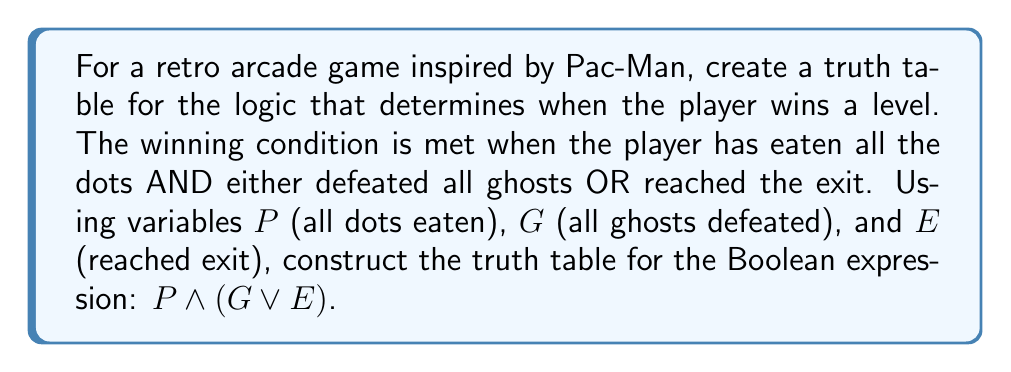What is the answer to this math problem? Let's approach this step-by-step:

1) First, we need to identify the variables:
   P: All dots eaten
   G: All ghosts defeated
   E: Reached exit

2) The Boolean expression is: $P \wedge (G \vee E)$

3) To create a truth table, we need to consider all possible combinations of these variables. With 3 variables, we'll have $2^3 = 8$ rows.

4) Let's start with listing all combinations of P, G, and E:

   | P | G | E |
   |---|---|---|
   | 0 | 0 | 0 |
   | 0 | 0 | 1 |
   | 0 | 1 | 0 |
   | 0 | 1 | 1 |
   | 1 | 0 | 0 |
   | 1 | 0 | 1 |
   | 1 | 1 | 0 |
   | 1 | 1 | 1 |

5) Now, let's evaluate $G \vee E$ first:

   | P | G | E | G ∨ E |
   |---|---|---|-------|
   | 0 | 0 | 0 |   0   |
   | 0 | 0 | 1 |   1   |
   | 0 | 1 | 0 |   1   |
   | 0 | 1 | 1 |   1   |
   | 1 | 0 | 0 |   0   |
   | 1 | 0 | 1 |   1   |
   | 1 | 1 | 0 |   1   |
   | 1 | 1 | 1 |   1   |

6) Finally, we can evaluate $P \wedge (G \vee E)$:

   | P | G | E | G ∨ E | P ∧ (G ∨ E) |
   |---|---|---|-------|-------------|
   | 0 | 0 | 0 |   0   |      0      |
   | 0 | 0 | 1 |   1   |      0      |
   | 0 | 1 | 0 |   1   |      0      |
   | 0 | 1 | 1 |   1   |      0      |
   | 1 | 0 | 0 |   0   |      0      |
   | 1 | 0 | 1 |   1   |      1      |
   | 1 | 1 | 0 |   1   |      1      |
   | 1 | 1 | 1 |   1   |      1      |

This completes our truth table for the given Boolean expression.
Answer: | P | G | E | P ∧ (G ∨ E) |
|---|---|---|-------------|
| 0 | 0 | 0 |      0      |
| 0 | 0 | 1 |      0      |
| 0 | 1 | 0 |      0      |
| 0 | 1 | 1 |      0      |
| 1 | 0 | 0 |      0      |
| 1 | 0 | 1 |      1      |
| 1 | 1 | 0 |      1      |
| 1 | 1 | 1 |      1      | 